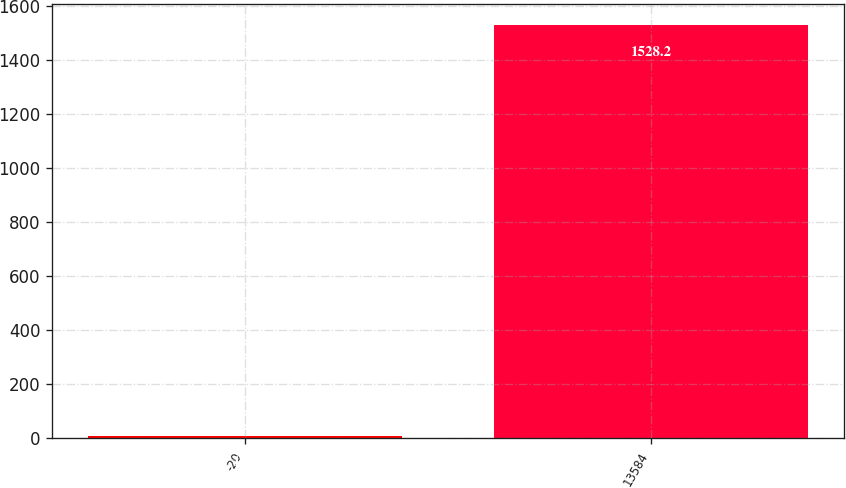<chart> <loc_0><loc_0><loc_500><loc_500><bar_chart><fcel>-20<fcel>13584<nl><fcel>10<fcel>1528.2<nl></chart> 